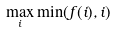<formula> <loc_0><loc_0><loc_500><loc_500>\max _ { i } \min ( f ( i ) , i )</formula> 